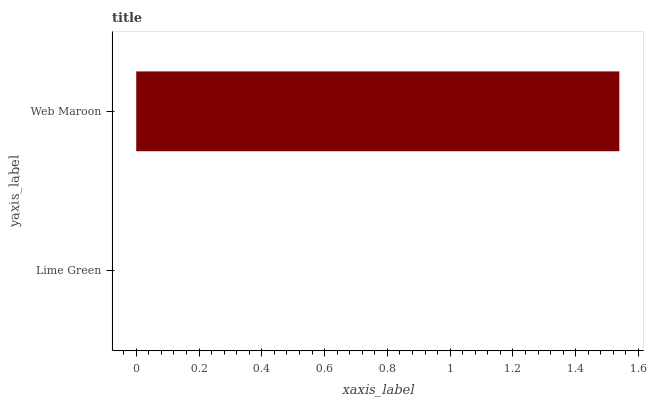Is Lime Green the minimum?
Answer yes or no. Yes. Is Web Maroon the maximum?
Answer yes or no. Yes. Is Web Maroon the minimum?
Answer yes or no. No. Is Web Maroon greater than Lime Green?
Answer yes or no. Yes. Is Lime Green less than Web Maroon?
Answer yes or no. Yes. Is Lime Green greater than Web Maroon?
Answer yes or no. No. Is Web Maroon less than Lime Green?
Answer yes or no. No. Is Web Maroon the high median?
Answer yes or no. Yes. Is Lime Green the low median?
Answer yes or no. Yes. Is Lime Green the high median?
Answer yes or no. No. Is Web Maroon the low median?
Answer yes or no. No. 